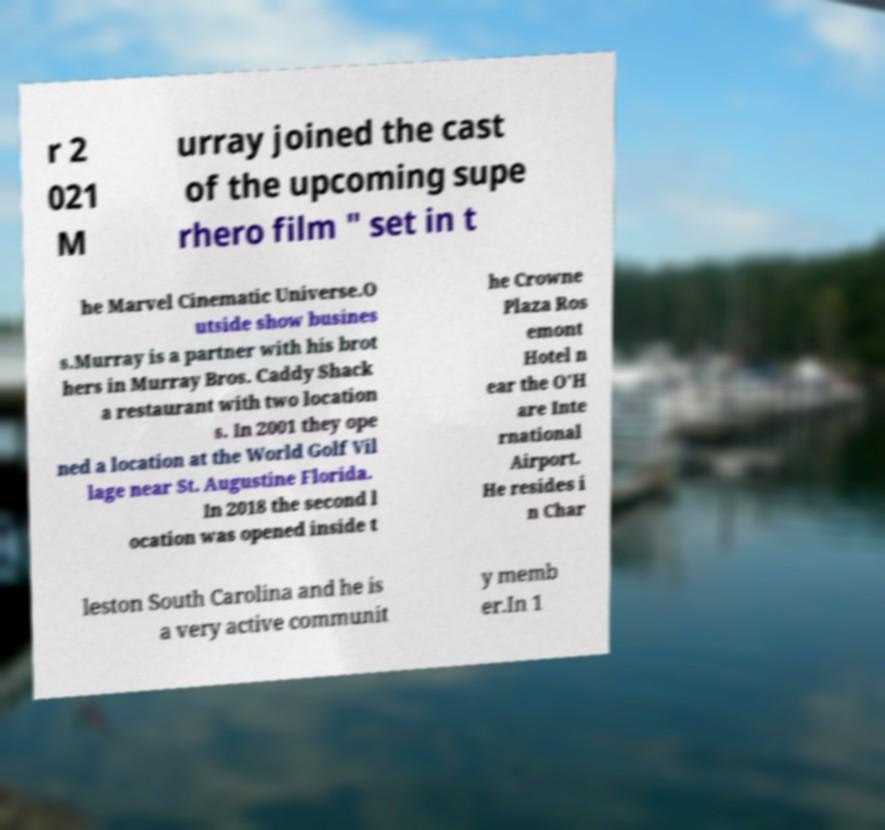There's text embedded in this image that I need extracted. Can you transcribe it verbatim? r 2 021 M urray joined the cast of the upcoming supe rhero film " set in t he Marvel Cinematic Universe.O utside show busines s.Murray is a partner with his brot hers in Murray Bros. Caddy Shack a restaurant with two location s. In 2001 they ope ned a location at the World Golf Vil lage near St. Augustine Florida. In 2018 the second l ocation was opened inside t he Crowne Plaza Ros emont Hotel n ear the O'H are Inte rnational Airport. He resides i n Char leston South Carolina and he is a very active communit y memb er.In 1 